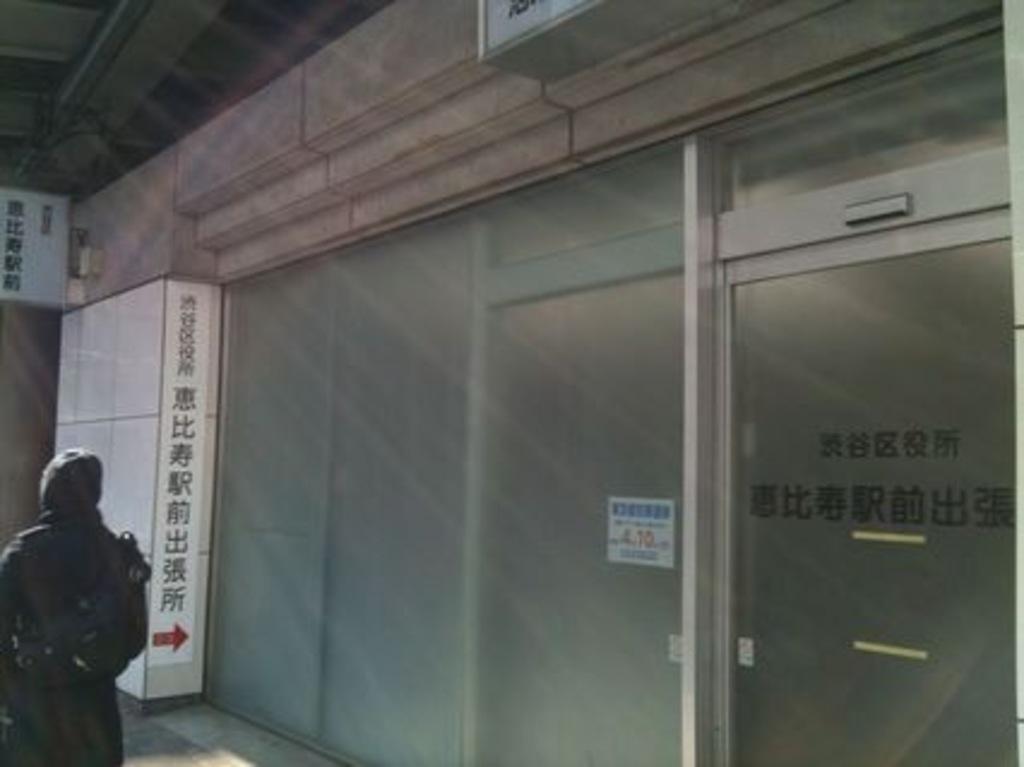Could you give a brief overview of what you see in this image? In this image I can see one person is standing, I can see this person is wearing black colour dress. I can also see few boards, a glass door and I can see something is written at many places. 